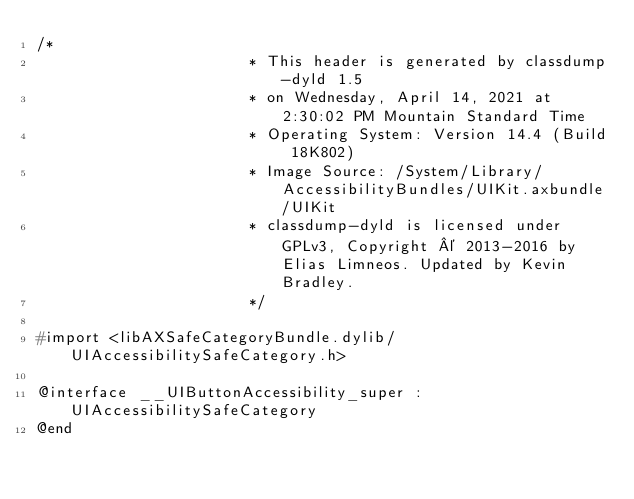<code> <loc_0><loc_0><loc_500><loc_500><_C_>/*
                       * This header is generated by classdump-dyld 1.5
                       * on Wednesday, April 14, 2021 at 2:30:02 PM Mountain Standard Time
                       * Operating System: Version 14.4 (Build 18K802)
                       * Image Source: /System/Library/AccessibilityBundles/UIKit.axbundle/UIKit
                       * classdump-dyld is licensed under GPLv3, Copyright © 2013-2016 by Elias Limneos. Updated by Kevin Bradley.
                       */

#import <libAXSafeCategoryBundle.dylib/UIAccessibilitySafeCategory.h>

@interface __UIButtonAccessibility_super : UIAccessibilitySafeCategory
@end

</code> 